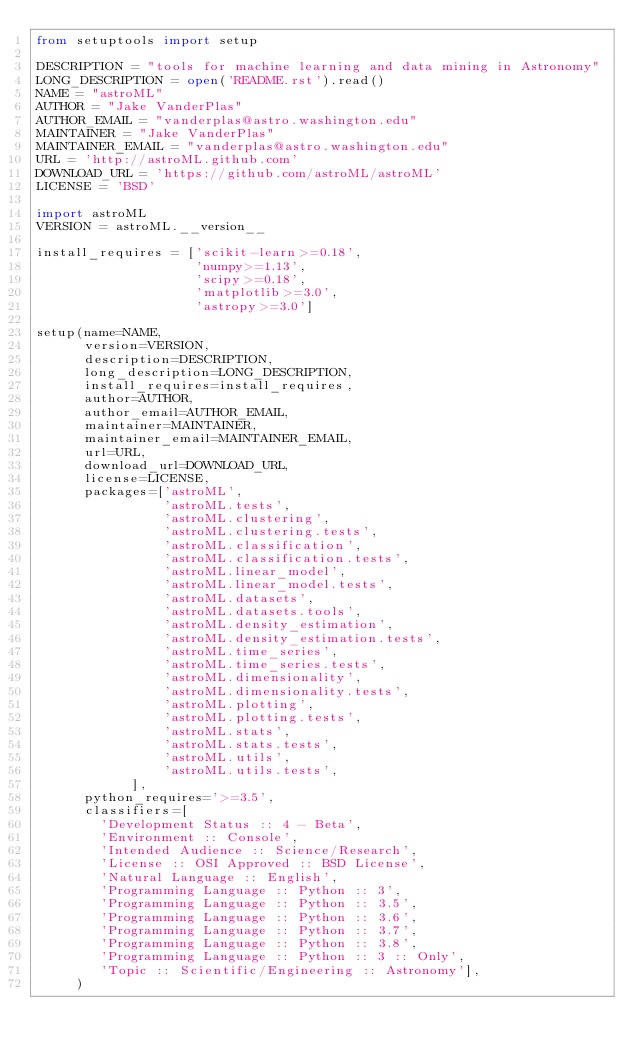Convert code to text. <code><loc_0><loc_0><loc_500><loc_500><_Python_>from setuptools import setup

DESCRIPTION = "tools for machine learning and data mining in Astronomy"
LONG_DESCRIPTION = open('README.rst').read()
NAME = "astroML"
AUTHOR = "Jake VanderPlas"
AUTHOR_EMAIL = "vanderplas@astro.washington.edu"
MAINTAINER = "Jake VanderPlas"
MAINTAINER_EMAIL = "vanderplas@astro.washington.edu"
URL = 'http://astroML.github.com'
DOWNLOAD_URL = 'https://github.com/astroML/astroML'
LICENSE = 'BSD'

import astroML
VERSION = astroML.__version__

install_requires = ['scikit-learn>=0.18',
                    'numpy>=1.13',
                    'scipy>=0.18',
                    'matplotlib>=3.0',
                    'astropy>=3.0']

setup(name=NAME,
      version=VERSION,
      description=DESCRIPTION,
      long_description=LONG_DESCRIPTION,
      install_requires=install_requires,
      author=AUTHOR,
      author_email=AUTHOR_EMAIL,
      maintainer=MAINTAINER,
      maintainer_email=MAINTAINER_EMAIL,
      url=URL,
      download_url=DOWNLOAD_URL,
      license=LICENSE,
      packages=['astroML',
                'astroML.tests',
                'astroML.clustering',
                'astroML.clustering.tests',
                'astroML.classification',
                'astroML.classification.tests',
                'astroML.linear_model',
                'astroML.linear_model.tests',
                'astroML.datasets',
                'astroML.datasets.tools',
                'astroML.density_estimation',
                'astroML.density_estimation.tests',
                'astroML.time_series',
                'astroML.time_series.tests',
                'astroML.dimensionality',
                'astroML.dimensionality.tests',
                'astroML.plotting',
                'astroML.plotting.tests',
                'astroML.stats',
                'astroML.stats.tests',
                'astroML.utils',
                'astroML.utils.tests',
            ],
      python_requires='>=3.5',
      classifiers=[
        'Development Status :: 4 - Beta',
        'Environment :: Console',
        'Intended Audience :: Science/Research',
        'License :: OSI Approved :: BSD License',
        'Natural Language :: English',
        'Programming Language :: Python :: 3',
        'Programming Language :: Python :: 3.5',
        'Programming Language :: Python :: 3.6',
        'Programming Language :: Python :: 3.7',
        'Programming Language :: Python :: 3.8',
        'Programming Language :: Python :: 3 :: Only',
        'Topic :: Scientific/Engineering :: Astronomy'],
     )
</code> 